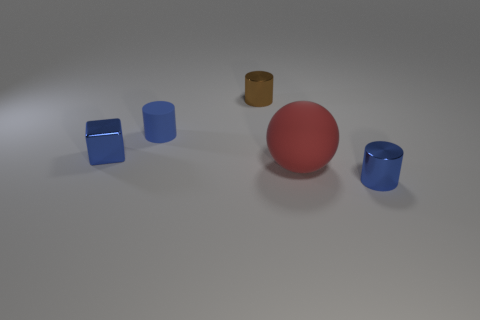Is there anything else that is the same shape as the tiny blue rubber thing?
Provide a succinct answer. Yes. There is another metal thing that is the same shape as the brown thing; what color is it?
Give a very brief answer. Blue. What is the color of the block that is the same material as the tiny brown object?
Offer a terse response. Blue. Are there the same number of things left of the small cube and red matte cubes?
Offer a very short reply. Yes. There is a metal thing to the right of the brown metal thing; does it have the same size as the rubber cylinder?
Provide a succinct answer. Yes. What is the color of the matte cylinder that is the same size as the cube?
Keep it short and to the point. Blue. Are there any big red rubber objects left of the blue shiny object that is behind the small metal object that is to the right of the brown cylinder?
Keep it short and to the point. No. There is a cylinder behind the tiny blue matte cylinder; what material is it?
Provide a short and direct response. Metal. Is the shape of the red thing the same as the rubber thing left of the small brown thing?
Provide a succinct answer. No. Are there the same number of tiny brown metallic cylinders behind the blue block and tiny metallic objects that are in front of the tiny brown cylinder?
Provide a succinct answer. No. 